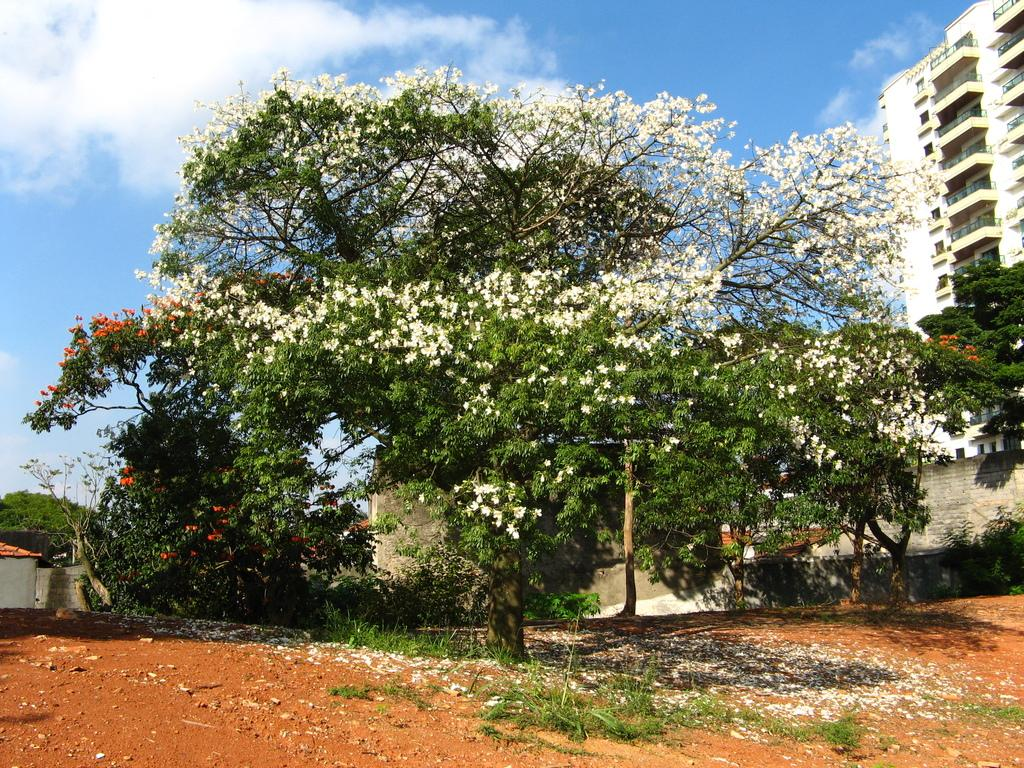What can be seen in the sky in the image? The sky with clouds is visible in the image. What type of structures are present in the image? There are buildings and a shed in the image. What type of vegetation is present in the image? Trees are present in the image. What is on the ground in the image? Shredded flowers are on the ground in the image. Where is the drawer located in the image? There is no drawer present in the image. What type of bubble can be seen in the image? There are no bubbles present in the image. 